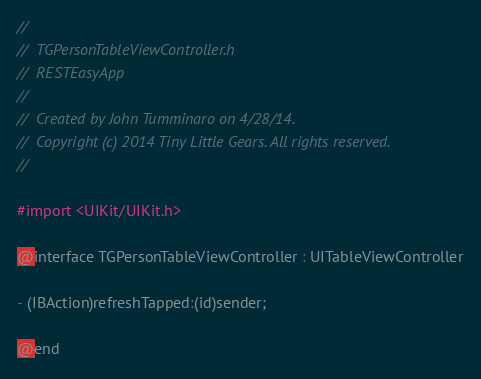<code> <loc_0><loc_0><loc_500><loc_500><_C_>//
//  TGPersonTableViewController.h
//  RESTEasyApp
//
//  Created by John Tumminaro on 4/28/14.
//  Copyright (c) 2014 Tiny Little Gears. All rights reserved.
//

#import <UIKit/UIKit.h>

@interface TGPersonTableViewController : UITableViewController

- (IBAction)refreshTapped:(id)sender;

@end
</code> 